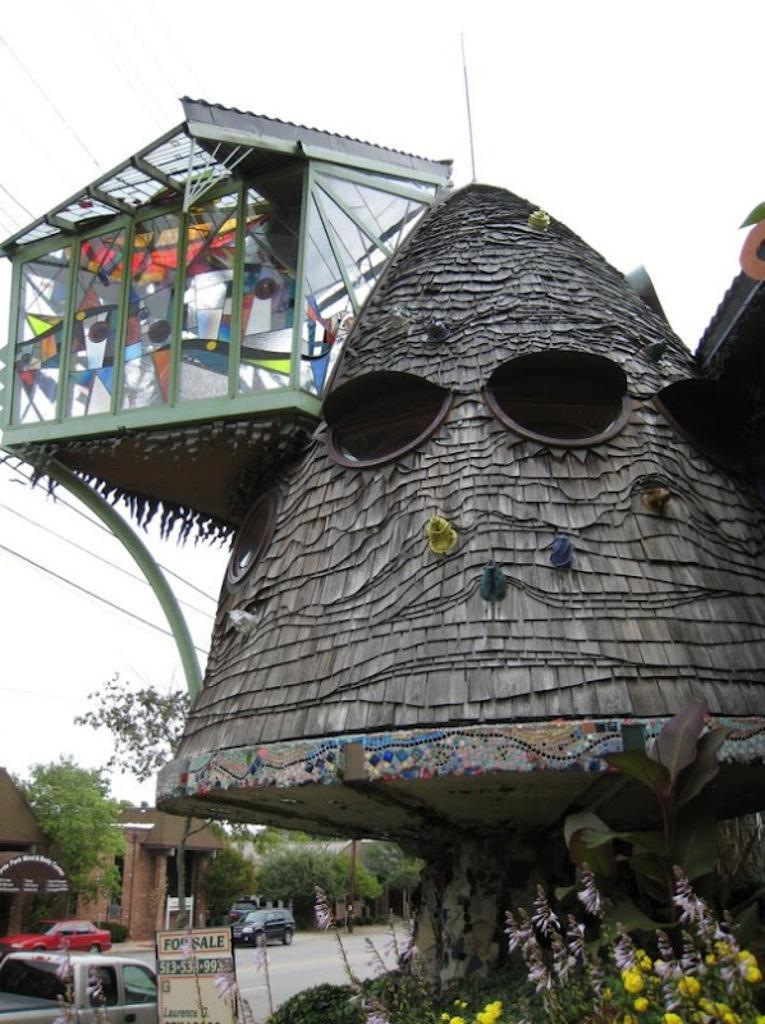Please provide a concise description of this image. In this picture we can see a house in the front, at the bottom there are some plants and flowers, on the left side there are cars and a board, we can see trees in the background, there is the sky at the top of the picture. 